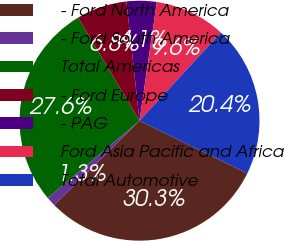Convert chart to OTSL. <chart><loc_0><loc_0><loc_500><loc_500><pie_chart><fcel>- Ford North America<fcel>- Ford South America<fcel>Total Americas<fcel>- Ford Europe<fcel>- PAG<fcel>Ford Asia Pacific and Africa<fcel>Total Automotive<nl><fcel>30.34%<fcel>1.29%<fcel>27.58%<fcel>6.81%<fcel>4.05%<fcel>9.56%<fcel>20.37%<nl></chart> 